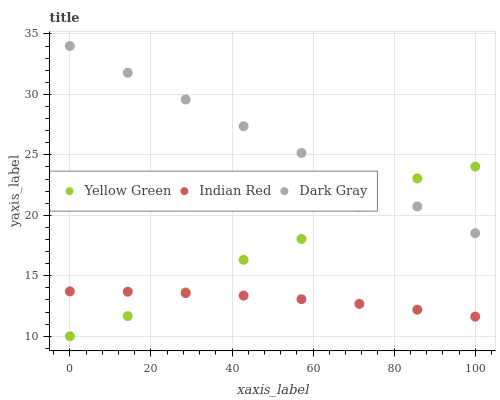Does Indian Red have the minimum area under the curve?
Answer yes or no. Yes. Does Dark Gray have the maximum area under the curve?
Answer yes or no. Yes. Does Yellow Green have the minimum area under the curve?
Answer yes or no. No. Does Yellow Green have the maximum area under the curve?
Answer yes or no. No. Is Dark Gray the smoothest?
Answer yes or no. Yes. Is Yellow Green the roughest?
Answer yes or no. Yes. Is Indian Red the smoothest?
Answer yes or no. No. Is Indian Red the roughest?
Answer yes or no. No. Does Yellow Green have the lowest value?
Answer yes or no. Yes. Does Indian Red have the lowest value?
Answer yes or no. No. Does Dark Gray have the highest value?
Answer yes or no. Yes. Does Yellow Green have the highest value?
Answer yes or no. No. Is Indian Red less than Dark Gray?
Answer yes or no. Yes. Is Dark Gray greater than Indian Red?
Answer yes or no. Yes. Does Dark Gray intersect Yellow Green?
Answer yes or no. Yes. Is Dark Gray less than Yellow Green?
Answer yes or no. No. Is Dark Gray greater than Yellow Green?
Answer yes or no. No. Does Indian Red intersect Dark Gray?
Answer yes or no. No. 